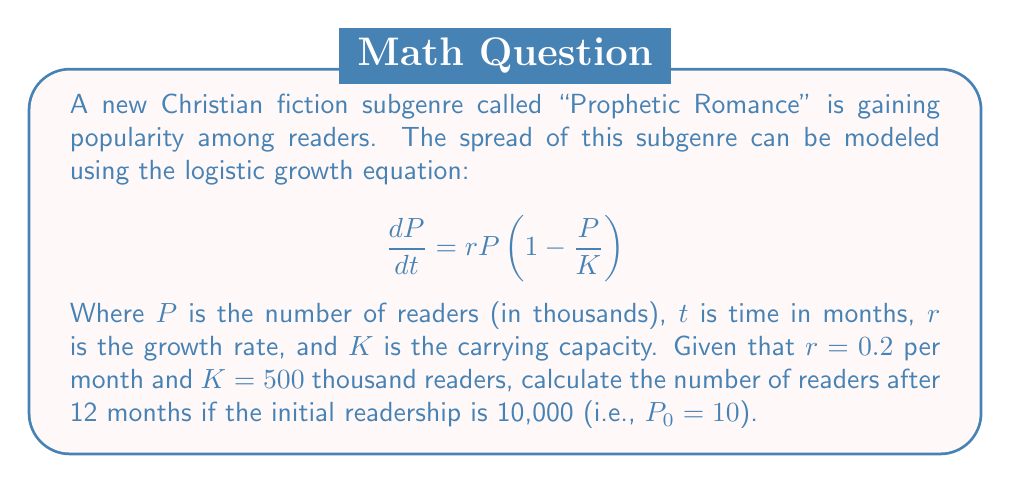What is the answer to this math problem? To solve this problem, we need to use the solution to the logistic growth equation:

$$P(t) = \frac{K}{1 + (\frac{K}{P_0} - 1)e^{-rt}}$$

Let's substitute the given values:
$K = 500$ (thousand readers)
$P_0 = 10$ (thousand readers)
$r = 0.2$ (per month)
$t = 12$ (months)

Now, let's calculate step-by-step:

1) First, calculate $\frac{K}{P_0} - 1$:
   $\frac{500}{10} - 1 = 50 - 1 = 49$

2) Next, calculate $e^{-rt}$:
   $e^{-0.2 \times 12} = e^{-2.4} \approx 0.0907$

3) Now, multiply the results from steps 1 and 2:
   $49 \times 0.0907 \approx 4.4443$

4) Add 1 to this result:
   $4.4443 + 1 = 5.4443$

5) Finally, divide $K$ by this result:
   $\frac{500}{5.4443} \approx 91.8410$

Therefore, after 12 months, the number of readers of the "Prophetic Romance" subgenre will be approximately 91,841.
Answer: 91,841 readers 